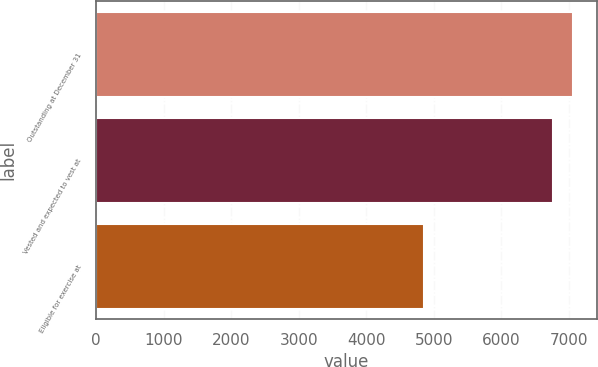Convert chart to OTSL. <chart><loc_0><loc_0><loc_500><loc_500><bar_chart><fcel>Outstanding at December 31<fcel>Vested and expected to vest at<fcel>Eligible for exercise at<nl><fcel>7062<fcel>6759<fcel>4849<nl></chart> 